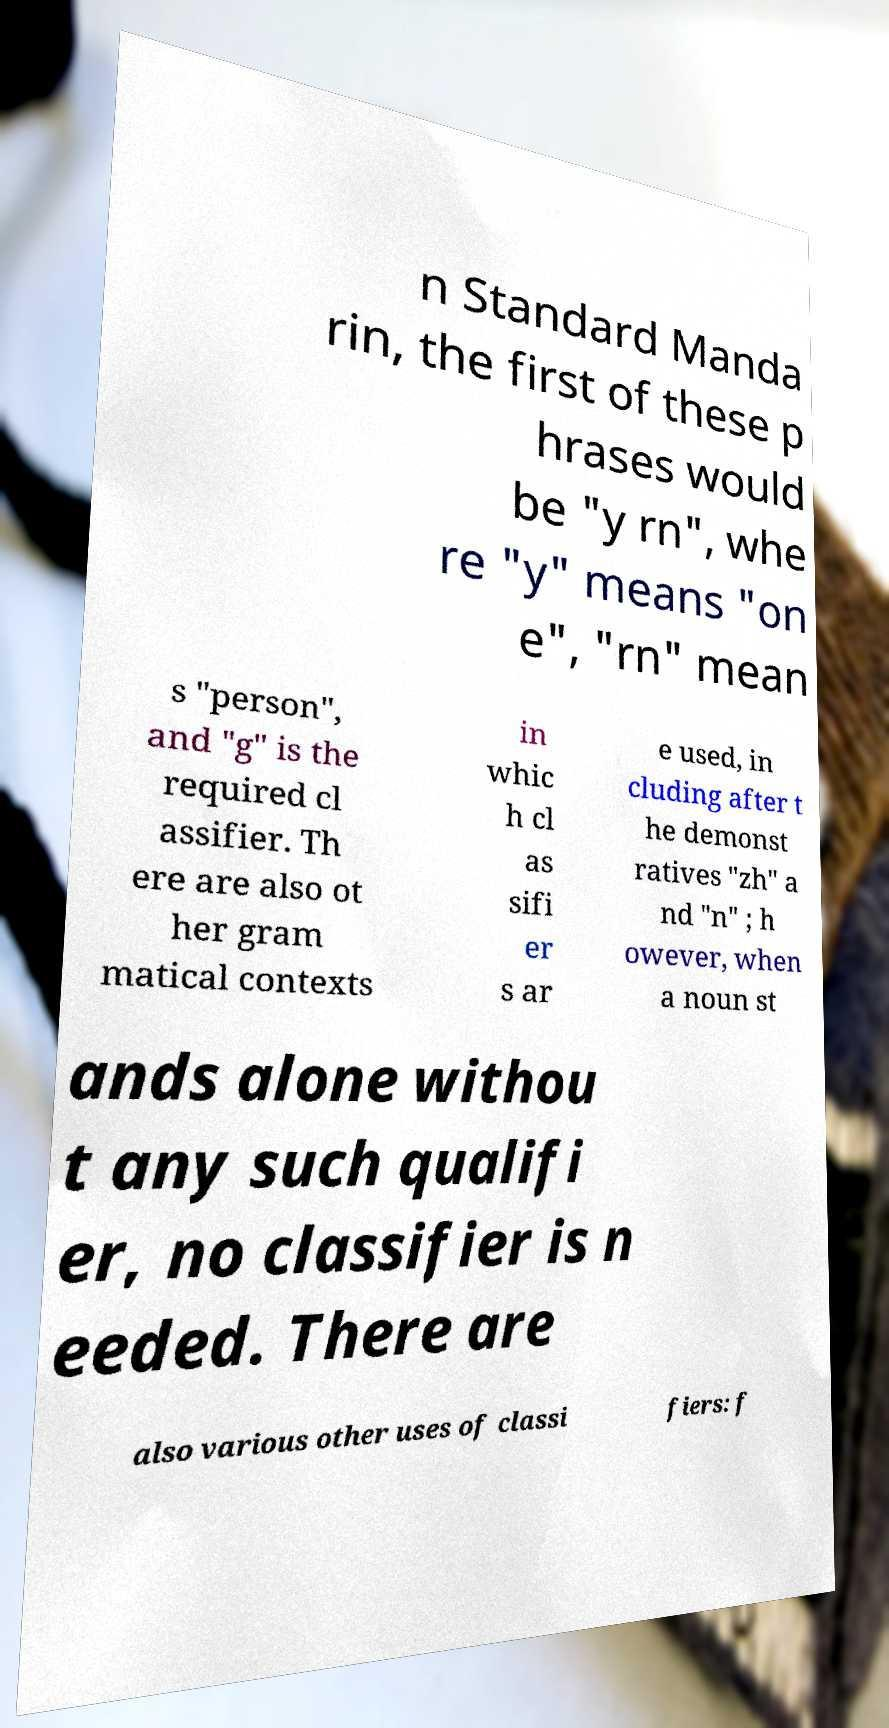For documentation purposes, I need the text within this image transcribed. Could you provide that? n Standard Manda rin, the first of these p hrases would be "y rn", whe re "y" means "on e", "rn" mean s "person", and "g" is the required cl assifier. Th ere are also ot her gram matical contexts in whic h cl as sifi er s ar e used, in cluding after t he demonst ratives "zh" a nd "n" ; h owever, when a noun st ands alone withou t any such qualifi er, no classifier is n eeded. There are also various other uses of classi fiers: f 